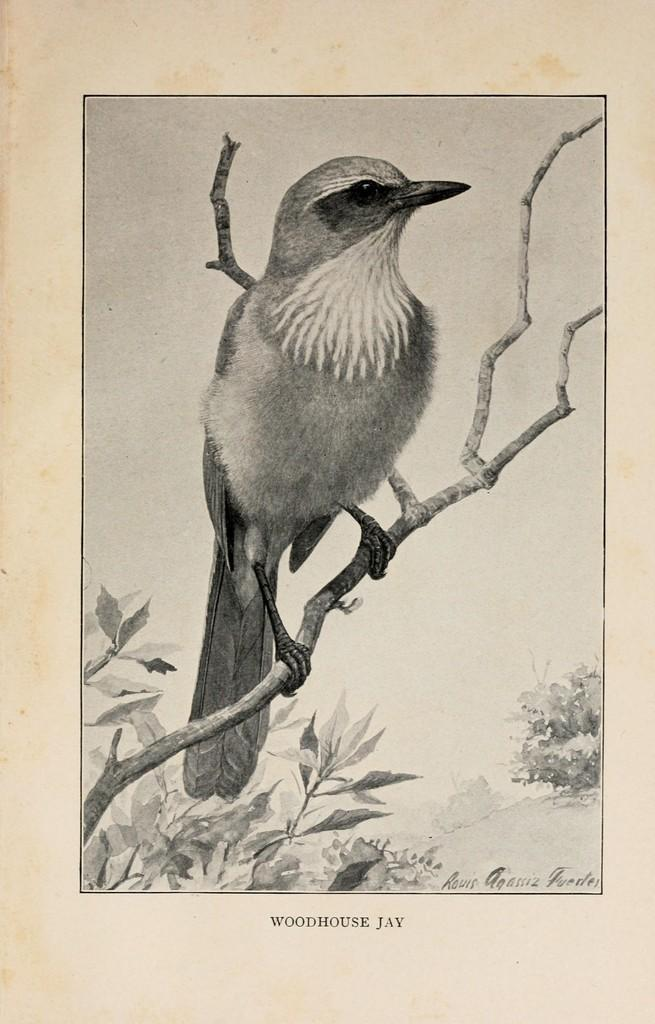What is the main subject of the image? The main subject of the image is a cover page. What can be seen in the background of the cover page? There is a bird standing on a branch and leaves visible in the image. What time does the clock on the cover page show? There is no clock present on the cover page in the image. 